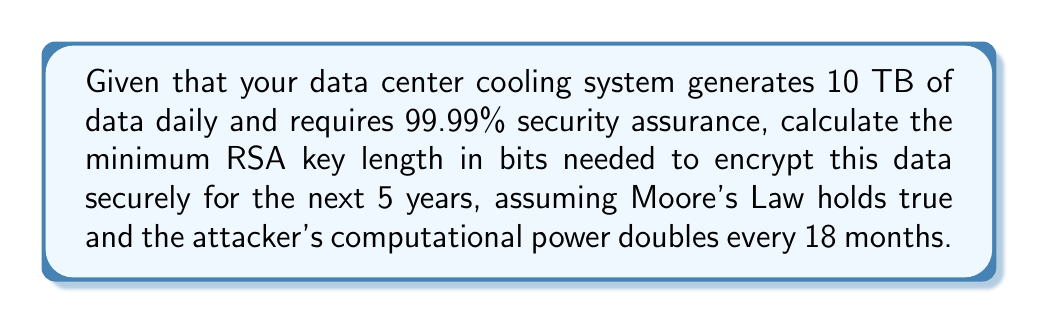Teach me how to tackle this problem. To determine the optimal RSA key length, we'll follow these steps:

1. Estimate the current computational power required to break a given key length.
2. Project the computational power 5 years into the future using Moore's Law.
3. Calculate the required key length based on the projected computational power.

Step 1: Current computational power
Let's assume that breaking a 2048-bit RSA key takes about $2^{80}$ operations with current technology.

Step 2: Future computational power
Moore's Law states that computational power doubles every 18 months. In 5 years, there are:
$$ \text{Number of doublings} = \frac{5 \text{ years} \times 12 \text{ months/year}}{18 \text{ months/doubling}} = 3.33 $$

The increase in computational power is:
$$ 2^{3.33} \approx 10 $$

So, in 5 years, the computational power will be about 10 times greater.

Step 3: Required key length
To maintain the same level of security, we need to increase the key length to compensate for the increased computational power. The number of operations should increase by a factor of 10:

$$ 2^{80} \times 10 = 2^{80} \times 2^{3.32} = 2^{83.32} $$

The key length scales linearly with the exponent, so we need to increase the key length by a factor of:

$$ \frac{83.32}{80} = 1.0415 $$

Therefore, the new key length should be:

$$ 2048 \text{ bits} \times 1.0415 = 2133 \text{ bits} $$

Rounding up to the nearest standard key size, we get 2176 bits.

To ensure 99.99% security assurance, we should add an extra margin. A common practice is to use the next standard key size, which is 3072 bits.
Answer: 3072 bits 